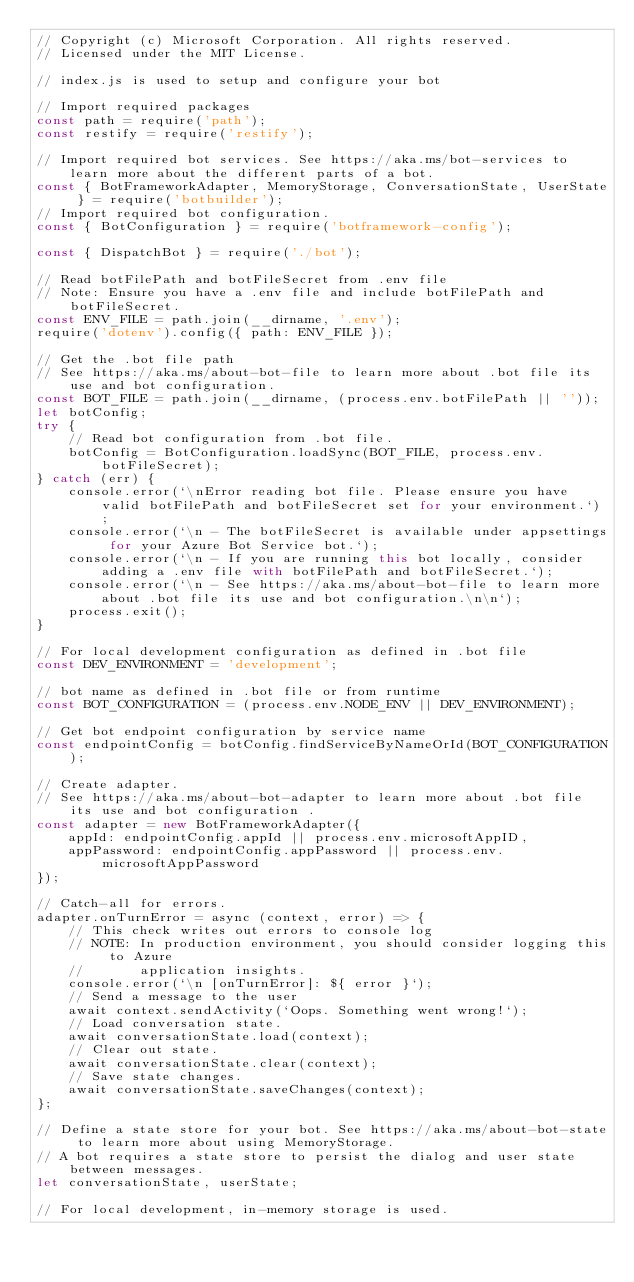<code> <loc_0><loc_0><loc_500><loc_500><_JavaScript_>// Copyright (c) Microsoft Corporation. All rights reserved.
// Licensed under the MIT License.

// index.js is used to setup and configure your bot

// Import required packages
const path = require('path');
const restify = require('restify');

// Import required bot services. See https://aka.ms/bot-services to learn more about the different parts of a bot.
const { BotFrameworkAdapter, MemoryStorage, ConversationState, UserState } = require('botbuilder');
// Import required bot configuration.
const { BotConfiguration } = require('botframework-config');

const { DispatchBot } = require('./bot');

// Read botFilePath and botFileSecret from .env file
// Note: Ensure you have a .env file and include botFilePath and botFileSecret.
const ENV_FILE = path.join(__dirname, '.env');
require('dotenv').config({ path: ENV_FILE });

// Get the .bot file path
// See https://aka.ms/about-bot-file to learn more about .bot file its use and bot configuration.
const BOT_FILE = path.join(__dirname, (process.env.botFilePath || ''));
let botConfig;
try {
    // Read bot configuration from .bot file.
    botConfig = BotConfiguration.loadSync(BOT_FILE, process.env.botFileSecret);
} catch (err) {
    console.error(`\nError reading bot file. Please ensure you have valid botFilePath and botFileSecret set for your environment.`);
    console.error(`\n - The botFileSecret is available under appsettings for your Azure Bot Service bot.`);
    console.error(`\n - If you are running this bot locally, consider adding a .env file with botFilePath and botFileSecret.`);
    console.error(`\n - See https://aka.ms/about-bot-file to learn more about .bot file its use and bot configuration.\n\n`);
    process.exit();
}

// For local development configuration as defined in .bot file
const DEV_ENVIRONMENT = 'development';

// bot name as defined in .bot file or from runtime
const BOT_CONFIGURATION = (process.env.NODE_ENV || DEV_ENVIRONMENT);

// Get bot endpoint configuration by service name
const endpointConfig = botConfig.findServiceByNameOrId(BOT_CONFIGURATION);

// Create adapter.
// See https://aka.ms/about-bot-adapter to learn more about .bot file its use and bot configuration .
const adapter = new BotFrameworkAdapter({
    appId: endpointConfig.appId || process.env.microsoftAppID,
    appPassword: endpointConfig.appPassword || process.env.microsoftAppPassword
});

// Catch-all for errors.
adapter.onTurnError = async (context, error) => {
    // This check writes out errors to console log
    // NOTE: In production environment, you should consider logging this to Azure
    //       application insights.
    console.error(`\n [onTurnError]: ${ error }`);
    // Send a message to the user
    await context.sendActivity(`Oops. Something went wrong!`);
    // Load conversation state.
    await conversationState.load(context);
    // Clear out state.
    await conversationState.clear(context);
    // Save state changes.
    await conversationState.saveChanges(context);
};

// Define a state store for your bot. See https://aka.ms/about-bot-state to learn more about using MemoryStorage.
// A bot requires a state store to persist the dialog and user state between messages.
let conversationState, userState;

// For local development, in-memory storage is used.</code> 